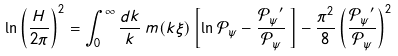Convert formula to latex. <formula><loc_0><loc_0><loc_500><loc_500>\ln \left ( \frac { H } { 2 \pi } \right ) ^ { 2 } = \int _ { 0 } ^ { \infty } \frac { d k } { k } \, m ( k \xi ) \left [ \ln \mathcal { P _ { \psi } } - \frac { \mathcal { P _ { \psi } } ^ { \prime } } { \mathcal { P _ { \psi } } } \, \right ] - \frac { \pi ^ { 2 } } { 8 } \left ( \frac { \mathcal { P _ { \psi } } ^ { \prime } } { \mathcal { P _ { \psi } } } \right ) ^ { 2 }</formula> 